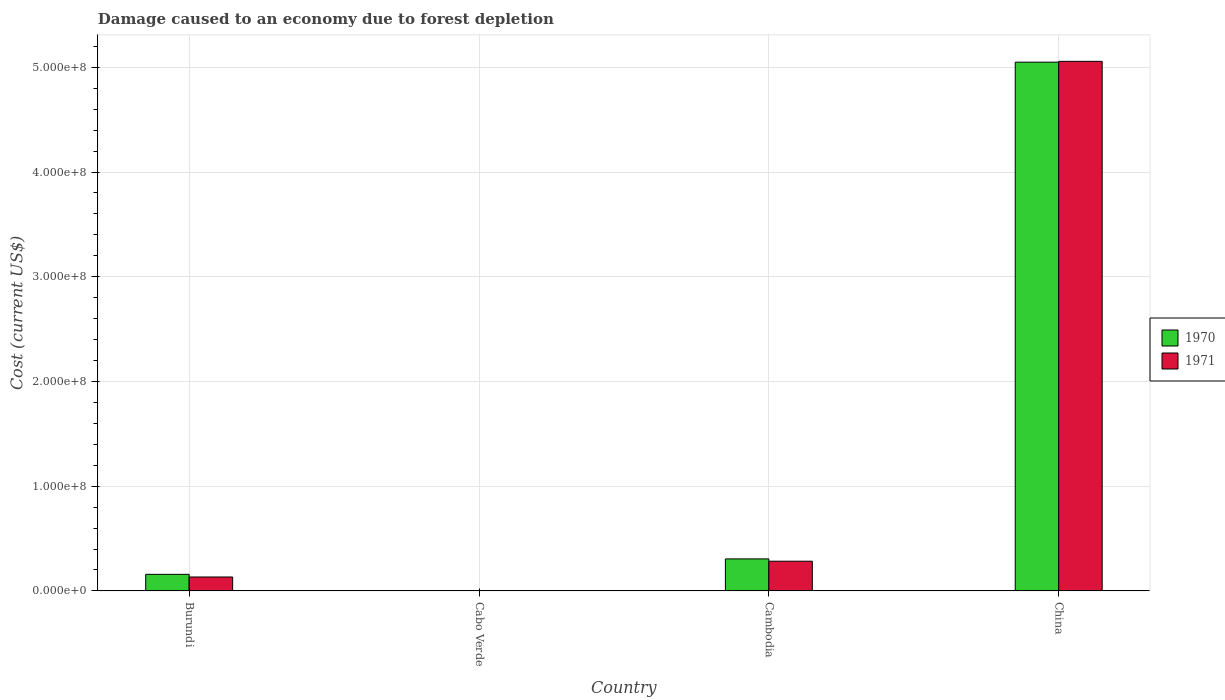How many groups of bars are there?
Your answer should be very brief. 4. Are the number of bars per tick equal to the number of legend labels?
Your answer should be compact. Yes. Are the number of bars on each tick of the X-axis equal?
Offer a very short reply. Yes. How many bars are there on the 1st tick from the right?
Your response must be concise. 2. What is the label of the 4th group of bars from the left?
Give a very brief answer. China. What is the cost of damage caused due to forest depletion in 1971 in Cambodia?
Give a very brief answer. 2.84e+07. Across all countries, what is the maximum cost of damage caused due to forest depletion in 1970?
Your response must be concise. 5.05e+08. Across all countries, what is the minimum cost of damage caused due to forest depletion in 1970?
Offer a terse response. 2.02e+05. In which country was the cost of damage caused due to forest depletion in 1971 maximum?
Keep it short and to the point. China. In which country was the cost of damage caused due to forest depletion in 1971 minimum?
Ensure brevity in your answer.  Cabo Verde. What is the total cost of damage caused due to forest depletion in 1971 in the graph?
Provide a short and direct response. 5.48e+08. What is the difference between the cost of damage caused due to forest depletion in 1971 in Cabo Verde and that in Cambodia?
Give a very brief answer. -2.82e+07. What is the difference between the cost of damage caused due to forest depletion in 1971 in Cambodia and the cost of damage caused due to forest depletion in 1970 in Burundi?
Give a very brief answer. 1.25e+07. What is the average cost of damage caused due to forest depletion in 1970 per country?
Provide a succinct answer. 1.38e+08. What is the difference between the cost of damage caused due to forest depletion of/in 1971 and cost of damage caused due to forest depletion of/in 1970 in China?
Offer a very short reply. 7.69e+05. What is the ratio of the cost of damage caused due to forest depletion in 1970 in Cabo Verde to that in Cambodia?
Make the answer very short. 0.01. Is the difference between the cost of damage caused due to forest depletion in 1971 in Cabo Verde and China greater than the difference between the cost of damage caused due to forest depletion in 1970 in Cabo Verde and China?
Ensure brevity in your answer.  No. What is the difference between the highest and the second highest cost of damage caused due to forest depletion in 1971?
Ensure brevity in your answer.  4.77e+08. What is the difference between the highest and the lowest cost of damage caused due to forest depletion in 1970?
Offer a terse response. 5.05e+08. Is the sum of the cost of damage caused due to forest depletion in 1970 in Cabo Verde and China greater than the maximum cost of damage caused due to forest depletion in 1971 across all countries?
Provide a short and direct response. No. What does the 2nd bar from the left in Cambodia represents?
Your answer should be compact. 1971. What does the 1st bar from the right in Burundi represents?
Provide a succinct answer. 1971. How many bars are there?
Your response must be concise. 8. How many countries are there in the graph?
Keep it short and to the point. 4. What is the difference between two consecutive major ticks on the Y-axis?
Your answer should be compact. 1.00e+08. Does the graph contain any zero values?
Your response must be concise. No. Where does the legend appear in the graph?
Make the answer very short. Center right. How many legend labels are there?
Your answer should be very brief. 2. How are the legend labels stacked?
Make the answer very short. Vertical. What is the title of the graph?
Keep it short and to the point. Damage caused to an economy due to forest depletion. What is the label or title of the X-axis?
Give a very brief answer. Country. What is the label or title of the Y-axis?
Provide a succinct answer. Cost (current US$). What is the Cost (current US$) in 1970 in Burundi?
Offer a very short reply. 1.58e+07. What is the Cost (current US$) of 1971 in Burundi?
Offer a very short reply. 1.33e+07. What is the Cost (current US$) of 1970 in Cabo Verde?
Your answer should be very brief. 2.02e+05. What is the Cost (current US$) in 1971 in Cabo Verde?
Offer a very short reply. 1.81e+05. What is the Cost (current US$) in 1970 in Cambodia?
Keep it short and to the point. 3.06e+07. What is the Cost (current US$) of 1971 in Cambodia?
Ensure brevity in your answer.  2.84e+07. What is the Cost (current US$) in 1970 in China?
Provide a succinct answer. 5.05e+08. What is the Cost (current US$) of 1971 in China?
Give a very brief answer. 5.06e+08. Across all countries, what is the maximum Cost (current US$) in 1970?
Offer a terse response. 5.05e+08. Across all countries, what is the maximum Cost (current US$) of 1971?
Offer a terse response. 5.06e+08. Across all countries, what is the minimum Cost (current US$) of 1970?
Make the answer very short. 2.02e+05. Across all countries, what is the minimum Cost (current US$) of 1971?
Provide a short and direct response. 1.81e+05. What is the total Cost (current US$) of 1970 in the graph?
Your answer should be very brief. 5.52e+08. What is the total Cost (current US$) of 1971 in the graph?
Your answer should be compact. 5.48e+08. What is the difference between the Cost (current US$) of 1970 in Burundi and that in Cabo Verde?
Make the answer very short. 1.56e+07. What is the difference between the Cost (current US$) of 1971 in Burundi and that in Cabo Verde?
Your response must be concise. 1.31e+07. What is the difference between the Cost (current US$) of 1970 in Burundi and that in Cambodia?
Ensure brevity in your answer.  -1.47e+07. What is the difference between the Cost (current US$) of 1971 in Burundi and that in Cambodia?
Offer a terse response. -1.51e+07. What is the difference between the Cost (current US$) in 1970 in Burundi and that in China?
Give a very brief answer. -4.89e+08. What is the difference between the Cost (current US$) in 1971 in Burundi and that in China?
Offer a terse response. -4.92e+08. What is the difference between the Cost (current US$) of 1970 in Cabo Verde and that in Cambodia?
Offer a very short reply. -3.04e+07. What is the difference between the Cost (current US$) of 1971 in Cabo Verde and that in Cambodia?
Your response must be concise. -2.82e+07. What is the difference between the Cost (current US$) of 1970 in Cabo Verde and that in China?
Provide a short and direct response. -5.05e+08. What is the difference between the Cost (current US$) in 1971 in Cabo Verde and that in China?
Give a very brief answer. -5.05e+08. What is the difference between the Cost (current US$) of 1970 in Cambodia and that in China?
Ensure brevity in your answer.  -4.74e+08. What is the difference between the Cost (current US$) in 1971 in Cambodia and that in China?
Provide a short and direct response. -4.77e+08. What is the difference between the Cost (current US$) of 1970 in Burundi and the Cost (current US$) of 1971 in Cabo Verde?
Provide a short and direct response. 1.57e+07. What is the difference between the Cost (current US$) in 1970 in Burundi and the Cost (current US$) in 1971 in Cambodia?
Provide a succinct answer. -1.25e+07. What is the difference between the Cost (current US$) in 1970 in Burundi and the Cost (current US$) in 1971 in China?
Give a very brief answer. -4.90e+08. What is the difference between the Cost (current US$) in 1970 in Cabo Verde and the Cost (current US$) in 1971 in Cambodia?
Your response must be concise. -2.82e+07. What is the difference between the Cost (current US$) in 1970 in Cabo Verde and the Cost (current US$) in 1971 in China?
Provide a short and direct response. -5.05e+08. What is the difference between the Cost (current US$) of 1970 in Cambodia and the Cost (current US$) of 1971 in China?
Provide a succinct answer. -4.75e+08. What is the average Cost (current US$) in 1970 per country?
Give a very brief answer. 1.38e+08. What is the average Cost (current US$) in 1971 per country?
Provide a short and direct response. 1.37e+08. What is the difference between the Cost (current US$) of 1970 and Cost (current US$) of 1971 in Burundi?
Your response must be concise. 2.54e+06. What is the difference between the Cost (current US$) in 1970 and Cost (current US$) in 1971 in Cabo Verde?
Your answer should be very brief. 2.17e+04. What is the difference between the Cost (current US$) of 1970 and Cost (current US$) of 1971 in Cambodia?
Provide a succinct answer. 2.21e+06. What is the difference between the Cost (current US$) in 1970 and Cost (current US$) in 1971 in China?
Your response must be concise. -7.69e+05. What is the ratio of the Cost (current US$) in 1970 in Burundi to that in Cabo Verde?
Offer a very short reply. 78.23. What is the ratio of the Cost (current US$) of 1971 in Burundi to that in Cabo Verde?
Provide a succinct answer. 73.58. What is the ratio of the Cost (current US$) in 1970 in Burundi to that in Cambodia?
Your answer should be very brief. 0.52. What is the ratio of the Cost (current US$) of 1971 in Burundi to that in Cambodia?
Your answer should be compact. 0.47. What is the ratio of the Cost (current US$) of 1970 in Burundi to that in China?
Keep it short and to the point. 0.03. What is the ratio of the Cost (current US$) of 1971 in Burundi to that in China?
Your response must be concise. 0.03. What is the ratio of the Cost (current US$) of 1970 in Cabo Verde to that in Cambodia?
Ensure brevity in your answer.  0.01. What is the ratio of the Cost (current US$) in 1971 in Cabo Verde to that in Cambodia?
Provide a succinct answer. 0.01. What is the ratio of the Cost (current US$) of 1971 in Cabo Verde to that in China?
Your answer should be compact. 0. What is the ratio of the Cost (current US$) of 1970 in Cambodia to that in China?
Your response must be concise. 0.06. What is the ratio of the Cost (current US$) in 1971 in Cambodia to that in China?
Offer a very short reply. 0.06. What is the difference between the highest and the second highest Cost (current US$) in 1970?
Offer a very short reply. 4.74e+08. What is the difference between the highest and the second highest Cost (current US$) in 1971?
Your answer should be very brief. 4.77e+08. What is the difference between the highest and the lowest Cost (current US$) in 1970?
Offer a very short reply. 5.05e+08. What is the difference between the highest and the lowest Cost (current US$) of 1971?
Your answer should be very brief. 5.05e+08. 